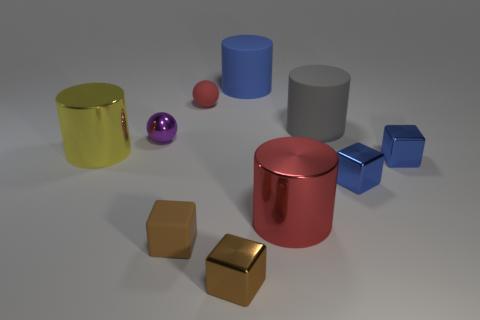Subtract 1 cylinders. How many cylinders are left? 3 Subtract all cyan cylinders. Subtract all brown balls. How many cylinders are left? 4 Subtract all cylinders. How many objects are left? 6 Subtract 0 brown cylinders. How many objects are left? 10 Subtract all red metallic cylinders. Subtract all tiny blue metal cubes. How many objects are left? 7 Add 4 brown objects. How many brown objects are left? 6 Add 9 purple metallic cubes. How many purple metallic cubes exist? 9 